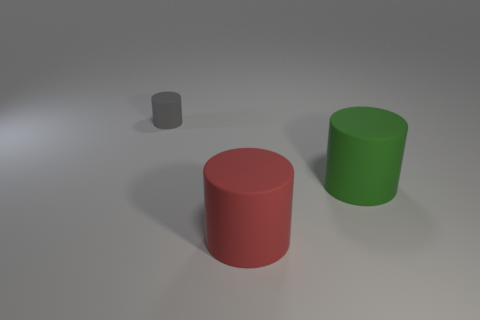Add 3 green matte things. How many objects exist? 6 Subtract all cylinders. Subtract all tiny green matte things. How many objects are left? 0 Add 2 big red things. How many big red things are left? 3 Add 1 small yellow spheres. How many small yellow spheres exist? 1 Subtract 1 green cylinders. How many objects are left? 2 